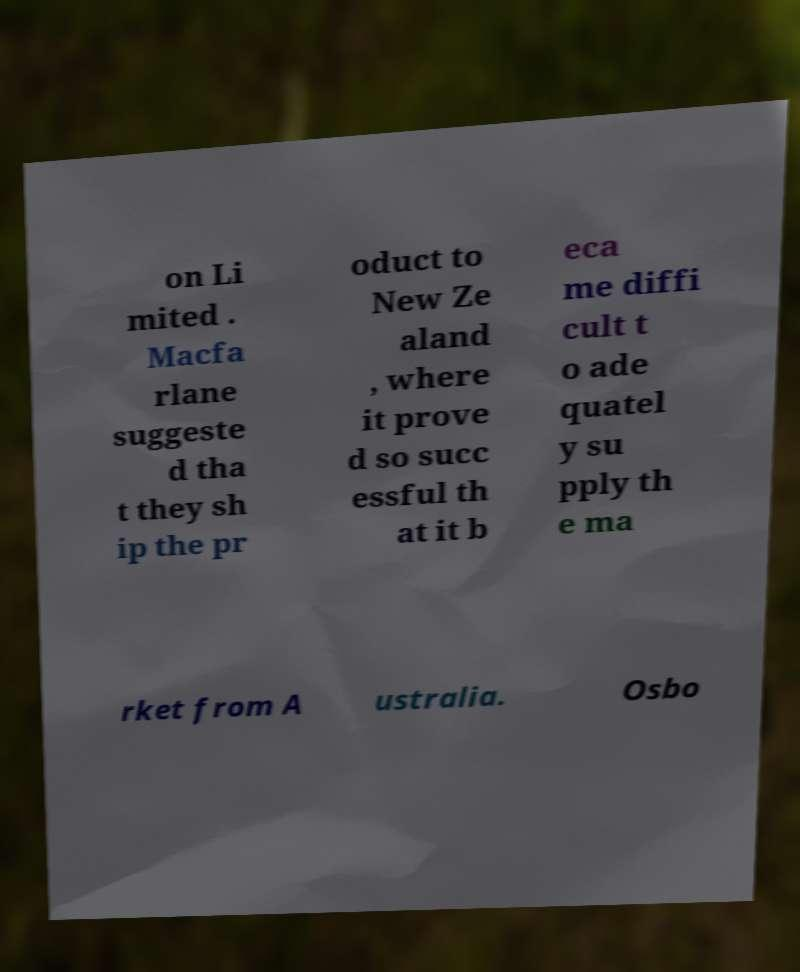Please identify and transcribe the text found in this image. on Li mited . Macfa rlane suggeste d tha t they sh ip the pr oduct to New Ze aland , where it prove d so succ essful th at it b eca me diffi cult t o ade quatel y su pply th e ma rket from A ustralia. Osbo 